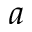Convert formula to latex. <formula><loc_0><loc_0><loc_500><loc_500>a</formula> 